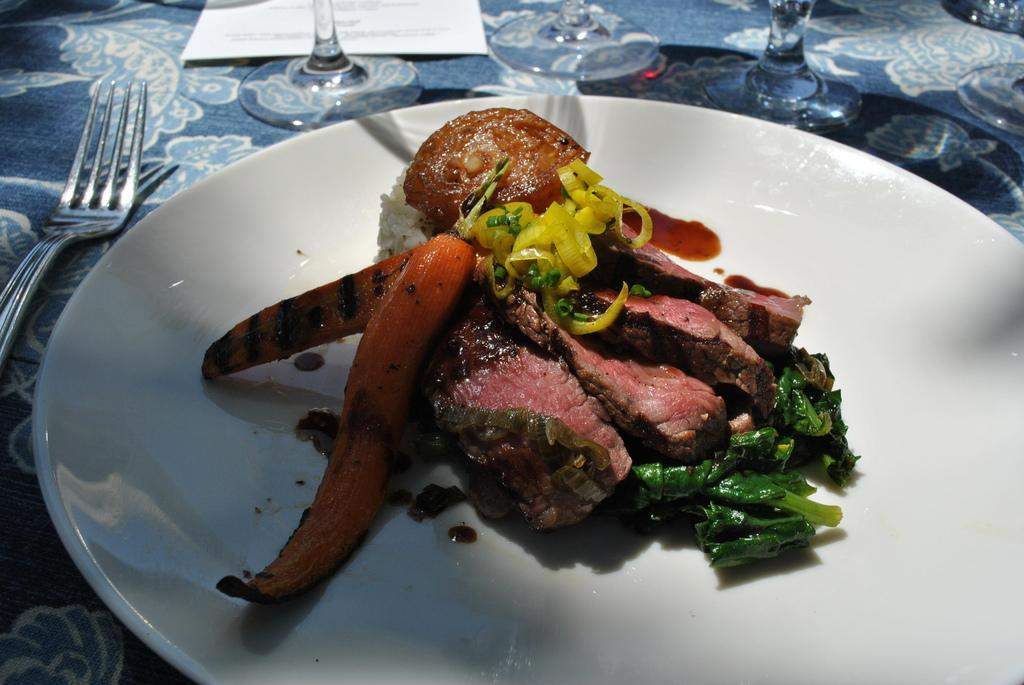What is located in the center of the image? There is a table in the center of the image. What is on the table? There is a plate containing food, a fork, a paper, and glasses on the table. What might be used for eating the food on the plate? A fork is present on the table for eating the food. What else is on the table besides the fork and plate? There is a paper and glasses on the table. How many clams are visible on the table in the image? There is no mention of clams in the image, so it is not possible to answer that question. 